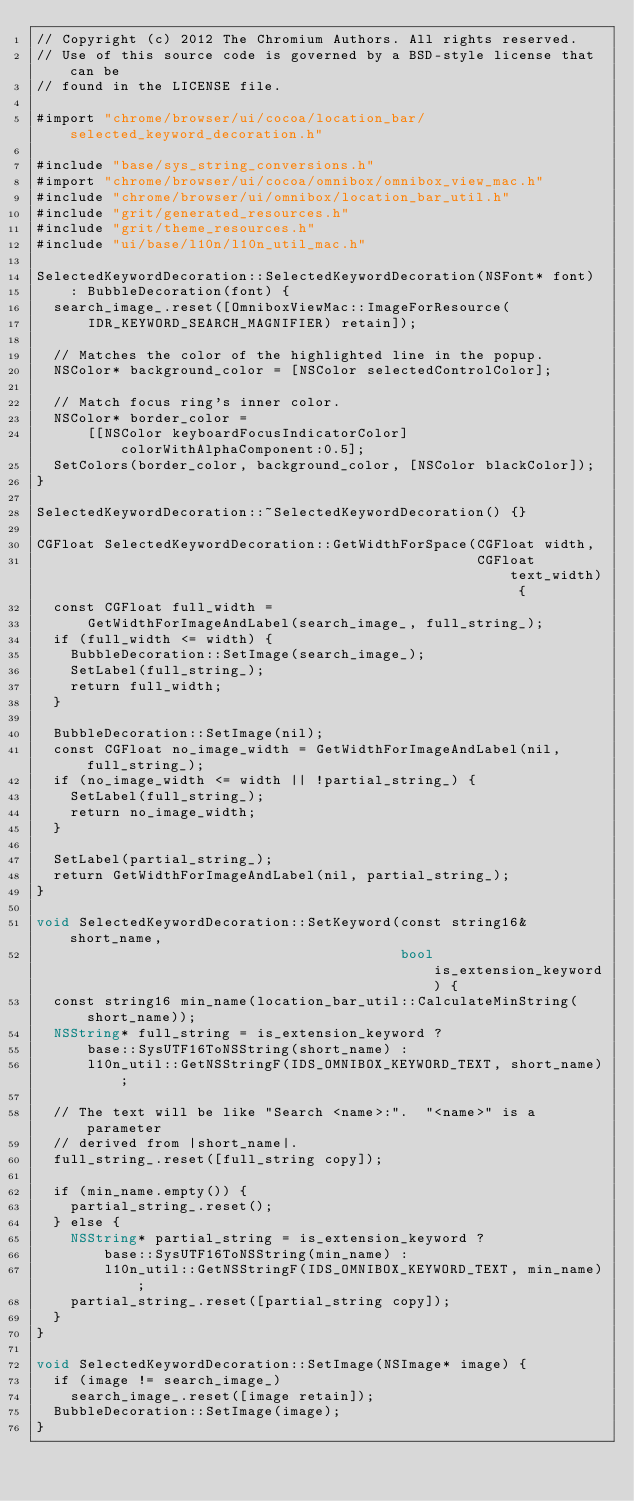<code> <loc_0><loc_0><loc_500><loc_500><_ObjectiveC_>// Copyright (c) 2012 The Chromium Authors. All rights reserved.
// Use of this source code is governed by a BSD-style license that can be
// found in the LICENSE file.

#import "chrome/browser/ui/cocoa/location_bar/selected_keyword_decoration.h"

#include "base/sys_string_conversions.h"
#import "chrome/browser/ui/cocoa/omnibox/omnibox_view_mac.h"
#include "chrome/browser/ui/omnibox/location_bar_util.h"
#include "grit/generated_resources.h"
#include "grit/theme_resources.h"
#include "ui/base/l10n/l10n_util_mac.h"

SelectedKeywordDecoration::SelectedKeywordDecoration(NSFont* font)
    : BubbleDecoration(font) {
  search_image_.reset([OmniboxViewMac::ImageForResource(
      IDR_KEYWORD_SEARCH_MAGNIFIER) retain]);

  // Matches the color of the highlighted line in the popup.
  NSColor* background_color = [NSColor selectedControlColor];

  // Match focus ring's inner color.
  NSColor* border_color =
      [[NSColor keyboardFocusIndicatorColor] colorWithAlphaComponent:0.5];
  SetColors(border_color, background_color, [NSColor blackColor]);
}

SelectedKeywordDecoration::~SelectedKeywordDecoration() {}

CGFloat SelectedKeywordDecoration::GetWidthForSpace(CGFloat width,
                                                    CGFloat text_width) {
  const CGFloat full_width =
      GetWidthForImageAndLabel(search_image_, full_string_);
  if (full_width <= width) {
    BubbleDecoration::SetImage(search_image_);
    SetLabel(full_string_);
    return full_width;
  }

  BubbleDecoration::SetImage(nil);
  const CGFloat no_image_width = GetWidthForImageAndLabel(nil, full_string_);
  if (no_image_width <= width || !partial_string_) {
    SetLabel(full_string_);
    return no_image_width;
  }

  SetLabel(partial_string_);
  return GetWidthForImageAndLabel(nil, partial_string_);
}

void SelectedKeywordDecoration::SetKeyword(const string16& short_name,
                                           bool is_extension_keyword) {
  const string16 min_name(location_bar_util::CalculateMinString(short_name));
  NSString* full_string = is_extension_keyword ?
      base::SysUTF16ToNSString(short_name) :
      l10n_util::GetNSStringF(IDS_OMNIBOX_KEYWORD_TEXT, short_name);

  // The text will be like "Search <name>:".  "<name>" is a parameter
  // derived from |short_name|.
  full_string_.reset([full_string copy]);

  if (min_name.empty()) {
    partial_string_.reset();
  } else {
    NSString* partial_string = is_extension_keyword ?
        base::SysUTF16ToNSString(min_name) :
        l10n_util::GetNSStringF(IDS_OMNIBOX_KEYWORD_TEXT, min_name);
    partial_string_.reset([partial_string copy]);
  }
}

void SelectedKeywordDecoration::SetImage(NSImage* image) {
  if (image != search_image_)
    search_image_.reset([image retain]);
  BubbleDecoration::SetImage(image);
}
</code> 